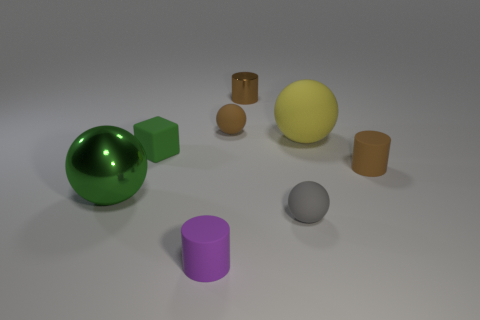Add 1 small purple matte cylinders. How many objects exist? 9 Subtract all blocks. How many objects are left? 7 Subtract 0 cyan balls. How many objects are left? 8 Subtract all green spheres. Subtract all big balls. How many objects are left? 5 Add 2 green spheres. How many green spheres are left? 3 Add 7 shiny spheres. How many shiny spheres exist? 8 